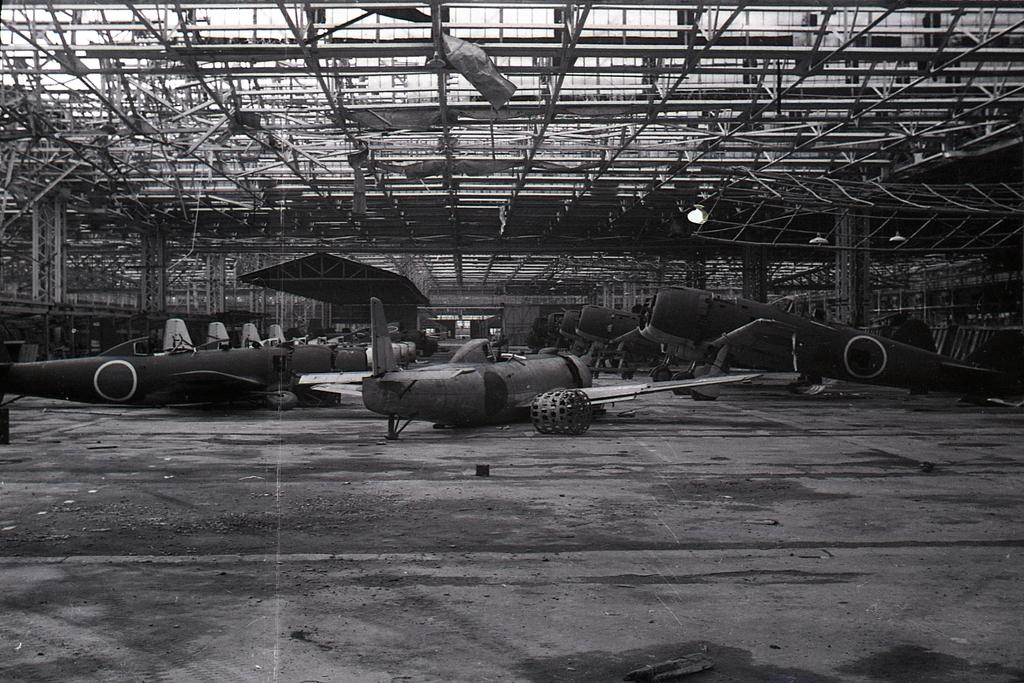What is the color scheme of the image? The image is black and white. What is the main subject of the image? There are multiple flying jets in the image. How are the jets arranged in the image? The jets are arranged in a row. What type of surface is visible in the image? There is a floor visible in the image. What is the upper boundary of the space in the image? There is a roof visible in the image. Can you see any plants or flowers in the image? There are no plants or flowers visible in the image; it primarily features flying jets. Is there an iron in the image? There is no iron present in the image. 